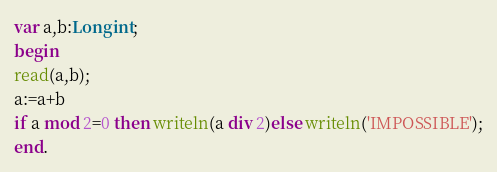<code> <loc_0><loc_0><loc_500><loc_500><_Pascal_>var a,b:Longint;
begin
read(a,b);
a:=a+b
if a mod 2=0 then writeln(a div 2)else writeln('IMPOSSIBLE');
end.</code> 